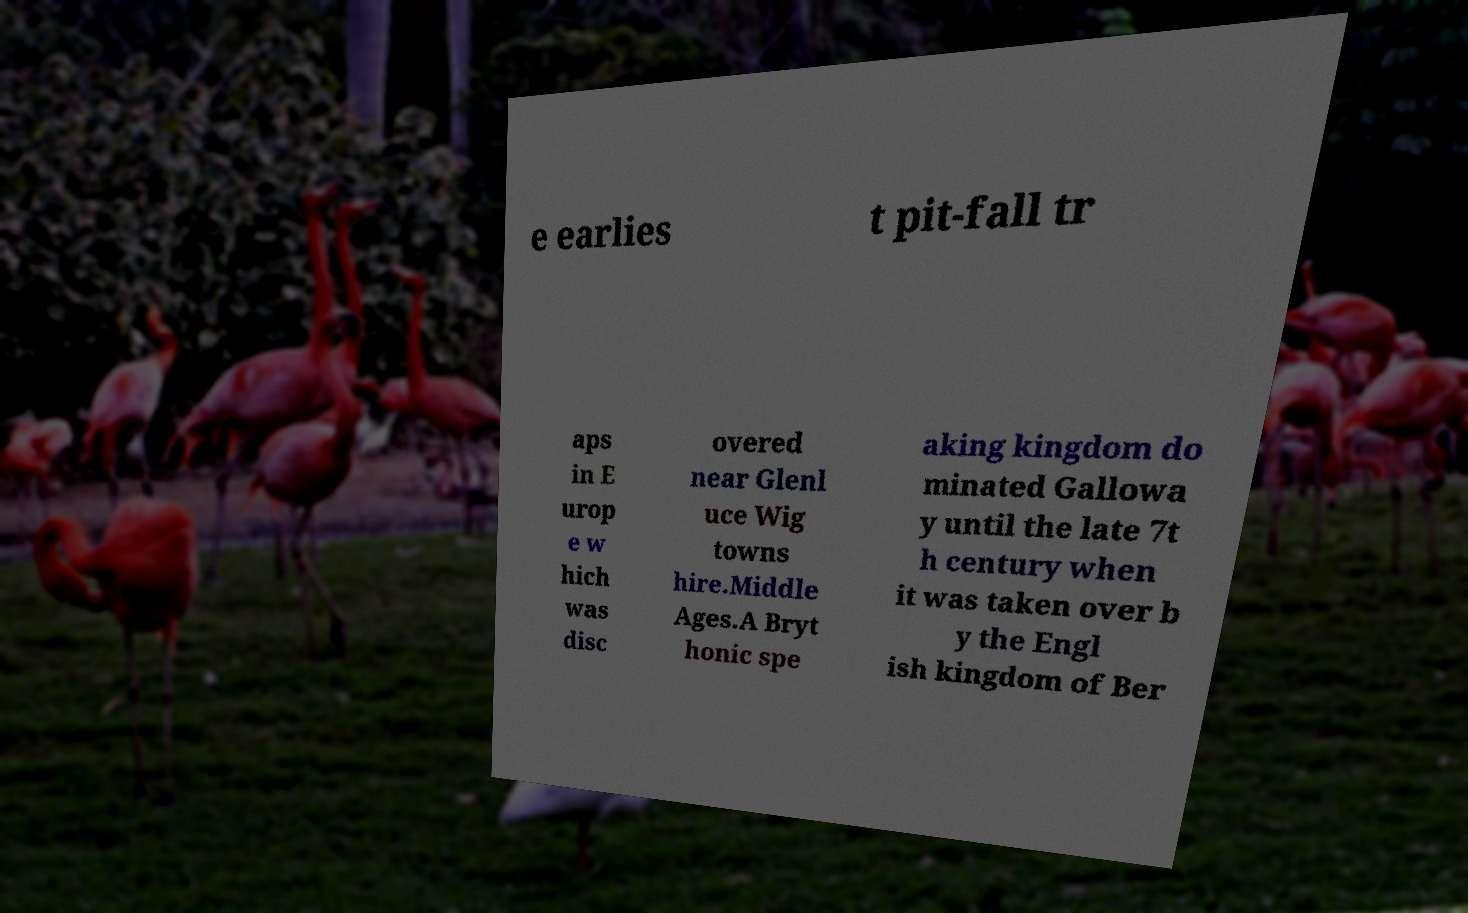Could you assist in decoding the text presented in this image and type it out clearly? e earlies t pit-fall tr aps in E urop e w hich was disc overed near Glenl uce Wig towns hire.Middle Ages.A Bryt honic spe aking kingdom do minated Gallowa y until the late 7t h century when it was taken over b y the Engl ish kingdom of Ber 